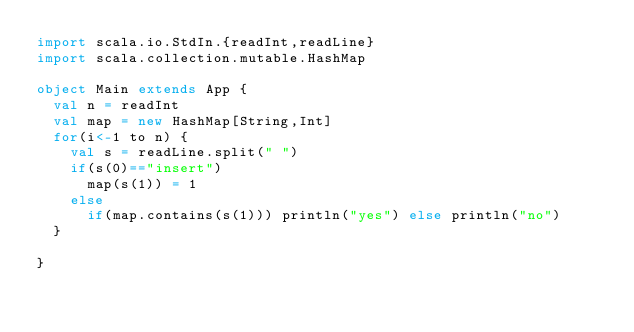<code> <loc_0><loc_0><loc_500><loc_500><_Scala_>import scala.io.StdIn.{readInt,readLine}
import scala.collection.mutable.HashMap

object Main extends App {
  val n = readInt
  val map = new HashMap[String,Int]
  for(i<-1 to n) {
    val s = readLine.split(" ")
    if(s(0)=="insert")
      map(s(1)) = 1
    else
      if(map.contains(s(1))) println("yes") else println("no")
  }

}</code> 